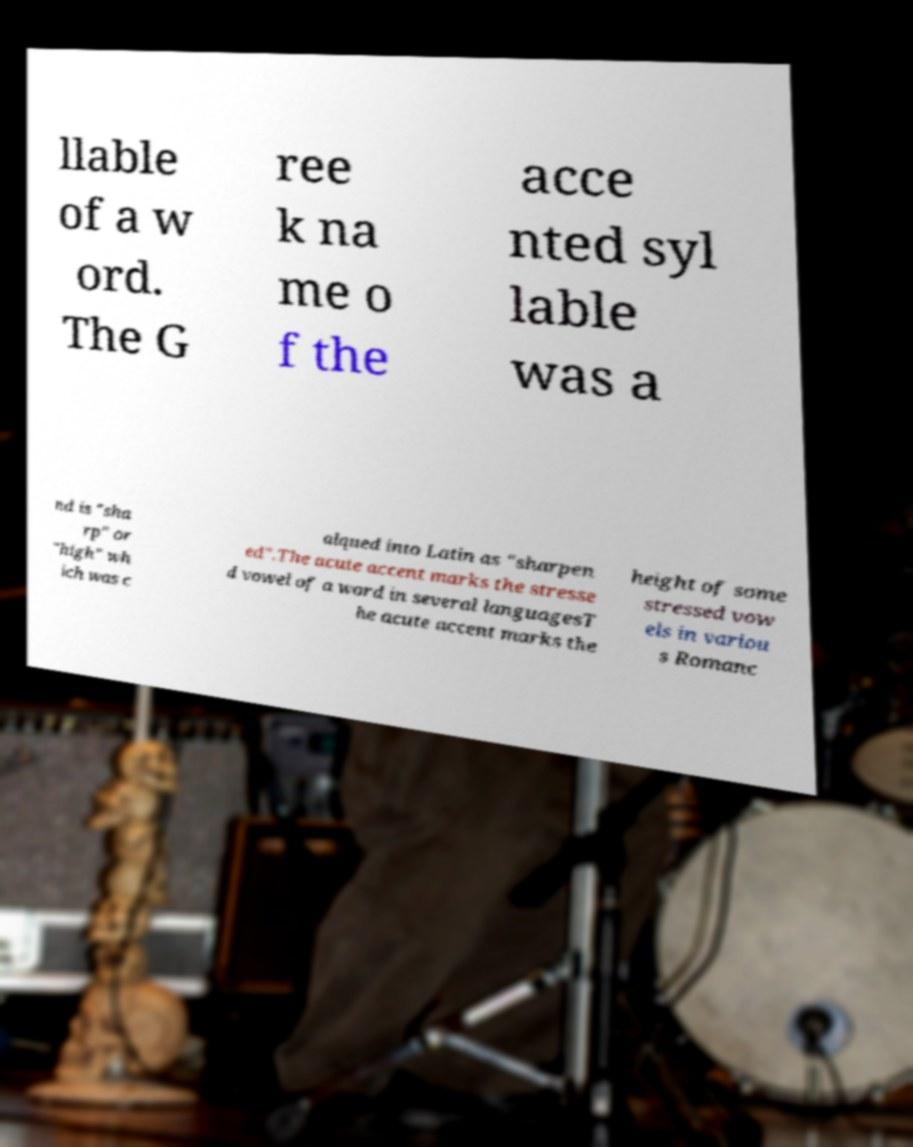There's text embedded in this image that I need extracted. Can you transcribe it verbatim? llable of a w ord. The G ree k na me o f the acce nted syl lable was a nd is "sha rp" or "high" wh ich was c alqued into Latin as "sharpen ed".The acute accent marks the stresse d vowel of a word in several languagesT he acute accent marks the height of some stressed vow els in variou s Romanc 